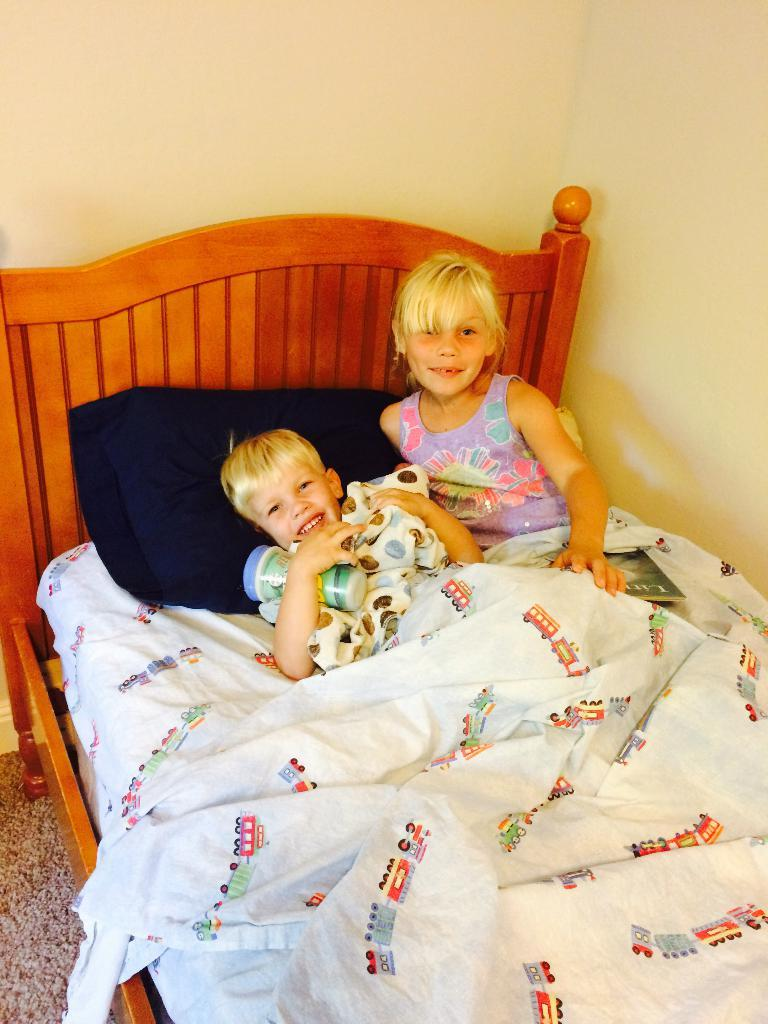How many children are present in the image? There are two children in the image. What are the children doing in the image? The children are lying on a bed. What are the children holding in the image? The children are holding a bottle, and one of them is holding a book. What is covering the bottle in the image? The bottle is covered with a blanket. What can be seen in the background of the image? There is a wall visible in the background of the image. In which direction are the children tasting the force in the image? There is no mention of tasting or force in the image; it features two children lying on a bed, holding a bottle and a book. 